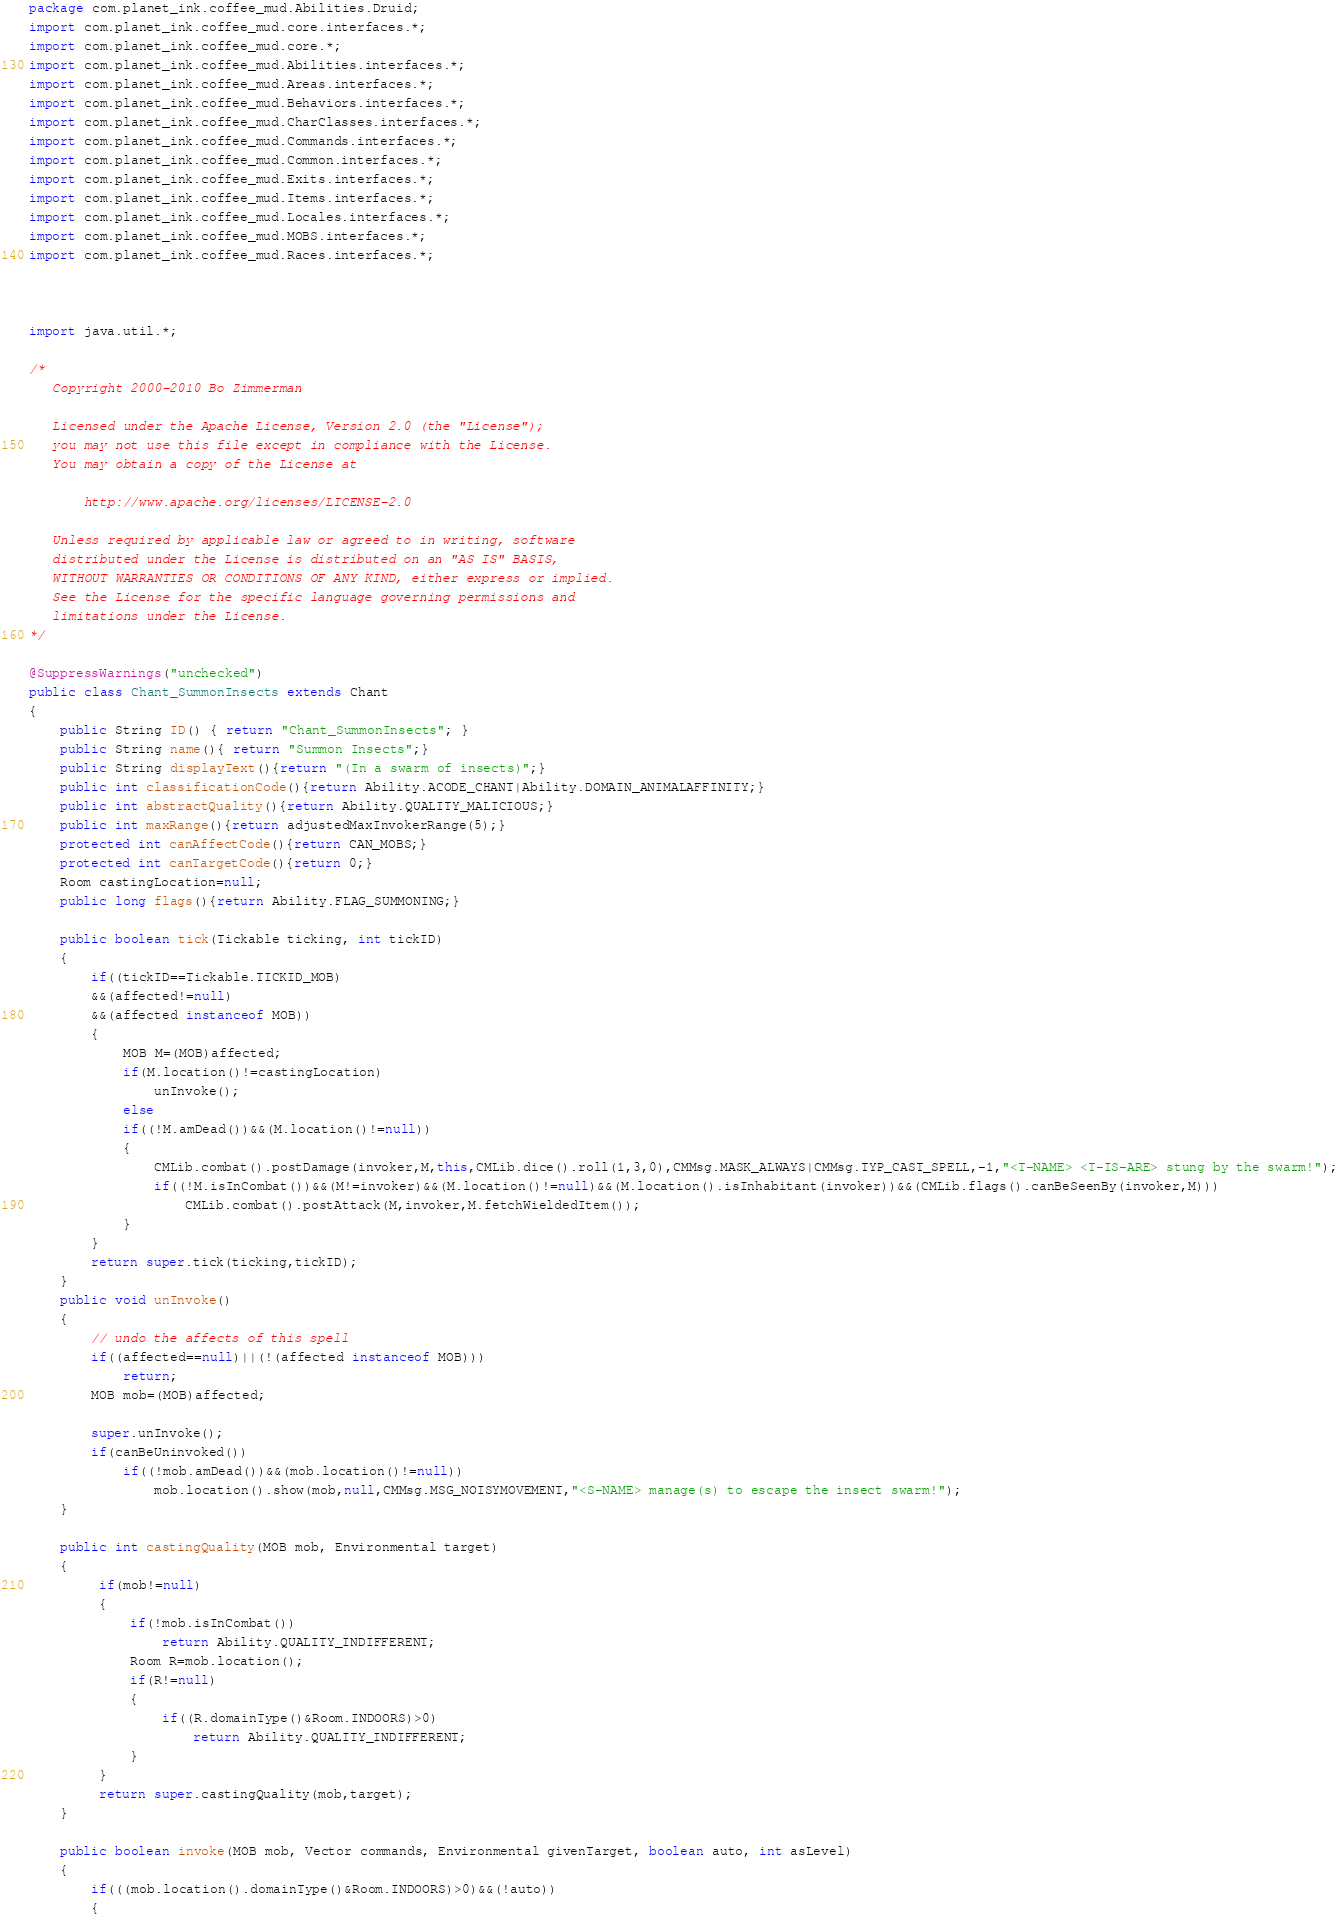<code> <loc_0><loc_0><loc_500><loc_500><_Java_>package com.planet_ink.coffee_mud.Abilities.Druid;
import com.planet_ink.coffee_mud.core.interfaces.*;
import com.planet_ink.coffee_mud.core.*;
import com.planet_ink.coffee_mud.Abilities.interfaces.*;
import com.planet_ink.coffee_mud.Areas.interfaces.*;
import com.planet_ink.coffee_mud.Behaviors.interfaces.*;
import com.planet_ink.coffee_mud.CharClasses.interfaces.*;
import com.planet_ink.coffee_mud.Commands.interfaces.*;
import com.planet_ink.coffee_mud.Common.interfaces.*;
import com.planet_ink.coffee_mud.Exits.interfaces.*;
import com.planet_ink.coffee_mud.Items.interfaces.*;
import com.planet_ink.coffee_mud.Locales.interfaces.*;
import com.planet_ink.coffee_mud.MOBS.interfaces.*;
import com.planet_ink.coffee_mud.Races.interfaces.*;



import java.util.*;

/* 
   Copyright 2000-2010 Bo Zimmerman

   Licensed under the Apache License, Version 2.0 (the "License");
   you may not use this file except in compliance with the License.
   You may obtain a copy of the License at

       http://www.apache.org/licenses/LICENSE-2.0

   Unless required by applicable law or agreed to in writing, software
   distributed under the License is distributed on an "AS IS" BASIS,
   WITHOUT WARRANTIES OR CONDITIONS OF ANY KIND, either express or implied.
   See the License for the specific language governing permissions and
   limitations under the License.
*/

@SuppressWarnings("unchecked")
public class Chant_SummonInsects extends Chant
{
	public String ID() { return "Chant_SummonInsects"; }
	public String name(){ return "Summon Insects";}
	public String displayText(){return "(In a swarm of insects)";}
    public int classificationCode(){return Ability.ACODE_CHANT|Ability.DOMAIN_ANIMALAFFINITY;}
	public int abstractQuality(){return Ability.QUALITY_MALICIOUS;}
	public int maxRange(){return adjustedMaxInvokerRange(5);}
	protected int canAffectCode(){return CAN_MOBS;}
	protected int canTargetCode(){return 0;}
	Room castingLocation=null;
	public long flags(){return Ability.FLAG_SUMMONING;}

	public boolean tick(Tickable ticking, int tickID)
	{
		if((tickID==Tickable.TICKID_MOB)
		&&(affected!=null)
		&&(affected instanceof MOB))
		{
			MOB M=(MOB)affected;
			if(M.location()!=castingLocation)
				unInvoke();
			else
			if((!M.amDead())&&(M.location()!=null))
            {
				CMLib.combat().postDamage(invoker,M,this,CMLib.dice().roll(1,3,0),CMMsg.MASK_ALWAYS|CMMsg.TYP_CAST_SPELL,-1,"<T-NAME> <T-IS-ARE> stung by the swarm!");
                if((!M.isInCombat())&&(M!=invoker)&&(M.location()!=null)&&(M.location().isInhabitant(invoker))&&(CMLib.flags().canBeSeenBy(invoker,M)))
                    CMLib.combat().postAttack(M,invoker,M.fetchWieldedItem());
            }
		}
		return super.tick(ticking,tickID);
	}
	public void unInvoke()
	{
		// undo the affects of this spell
		if((affected==null)||(!(affected instanceof MOB)))
			return;
		MOB mob=(MOB)affected;

		super.unInvoke();
		if(canBeUninvoked())
			if((!mob.amDead())&&(mob.location()!=null))
				mob.location().show(mob,null,CMMsg.MSG_NOISYMOVEMENT,"<S-NAME> manage(s) to escape the insect swarm!");
	}

    public int castingQuality(MOB mob, Environmental target)
    {
         if(mob!=null)
         {
             if(!mob.isInCombat())
                 return Ability.QUALITY_INDIFFERENT;
             Room R=mob.location();
             if(R!=null)
             {
                 if((R.domainType()&Room.INDOORS)>0)
                     return Ability.QUALITY_INDIFFERENT;
             }
         }
         return super.castingQuality(mob,target);
    }

	public boolean invoke(MOB mob, Vector commands, Environmental givenTarget, boolean auto, int asLevel)
	{
		if(((mob.location().domainType()&Room.INDOORS)>0)&&(!auto))
		{</code> 